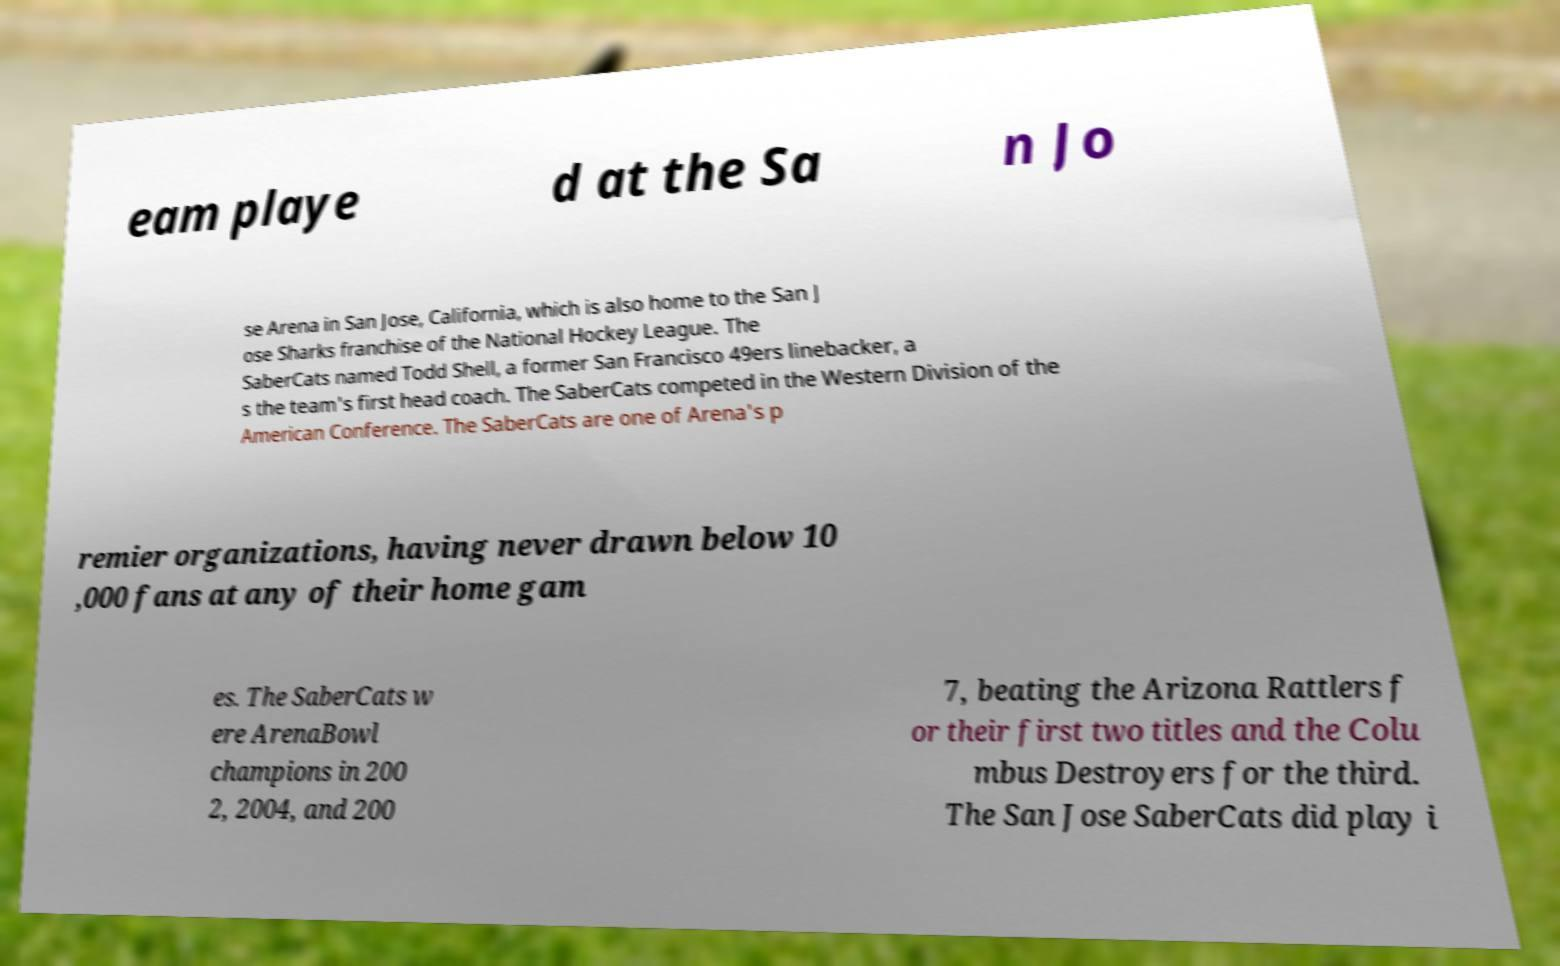Can you accurately transcribe the text from the provided image for me? eam playe d at the Sa n Jo se Arena in San Jose, California, which is also home to the San J ose Sharks franchise of the National Hockey League. The SaberCats named Todd Shell, a former San Francisco 49ers linebacker, a s the team's first head coach. The SaberCats competed in the Western Division of the American Conference. The SaberCats are one of Arena's p remier organizations, having never drawn below 10 ,000 fans at any of their home gam es. The SaberCats w ere ArenaBowl champions in 200 2, 2004, and 200 7, beating the Arizona Rattlers f or their first two titles and the Colu mbus Destroyers for the third. The San Jose SaberCats did play i 